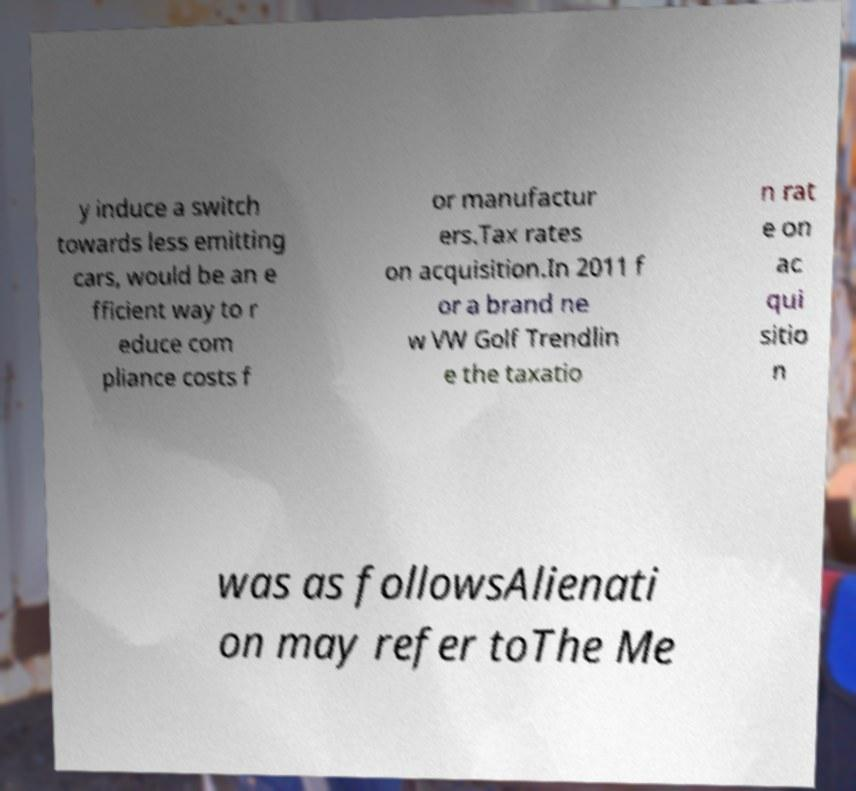Can you accurately transcribe the text from the provided image for me? y induce a switch towards less emitting cars, would be an e fficient way to r educe com pliance costs f or manufactur ers.Tax rates on acquisition.In 2011 f or a brand ne w VW Golf Trendlin e the taxatio n rat e on ac qui sitio n was as followsAlienati on may refer toThe Me 